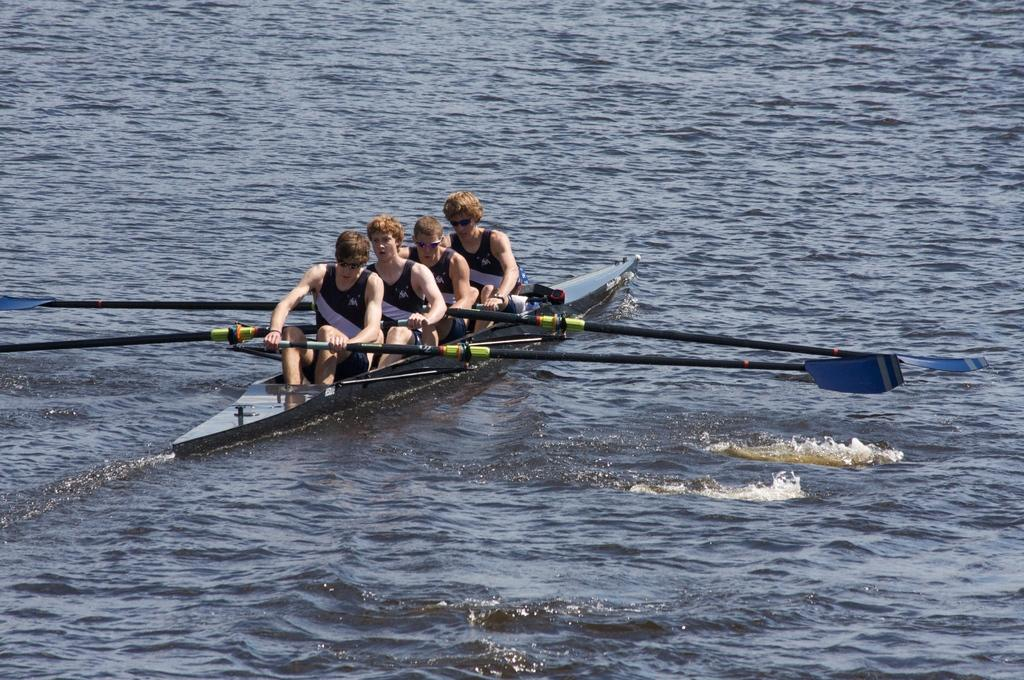How many people are in the image? There are four men in the image. What are the men doing in the image? The men are rowing on the water. What type of environment is visible in the image? There is water visible in the image, which might be in the sea. What type of history lesson is being taught by the men in the image? There is no indication in the image that the men are teaching a history lesson; they are rowing on the water. Can you tell me how many cups are present in the image? There is no cup visible in the image. 